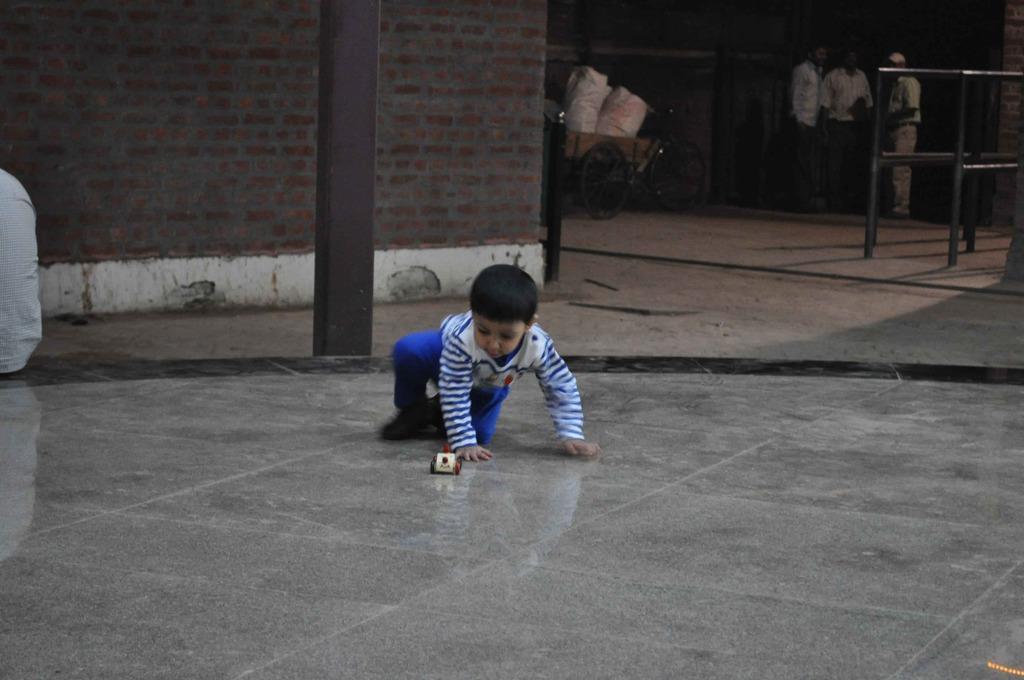Please provide a concise description of this image. In the center of the image there is a boy. In front of him there is a toy. At the bottom of the image there is a floor. In the background of the image there is a wall. There is a vehicle. There is a railing and we can see three people standing on the floor. 